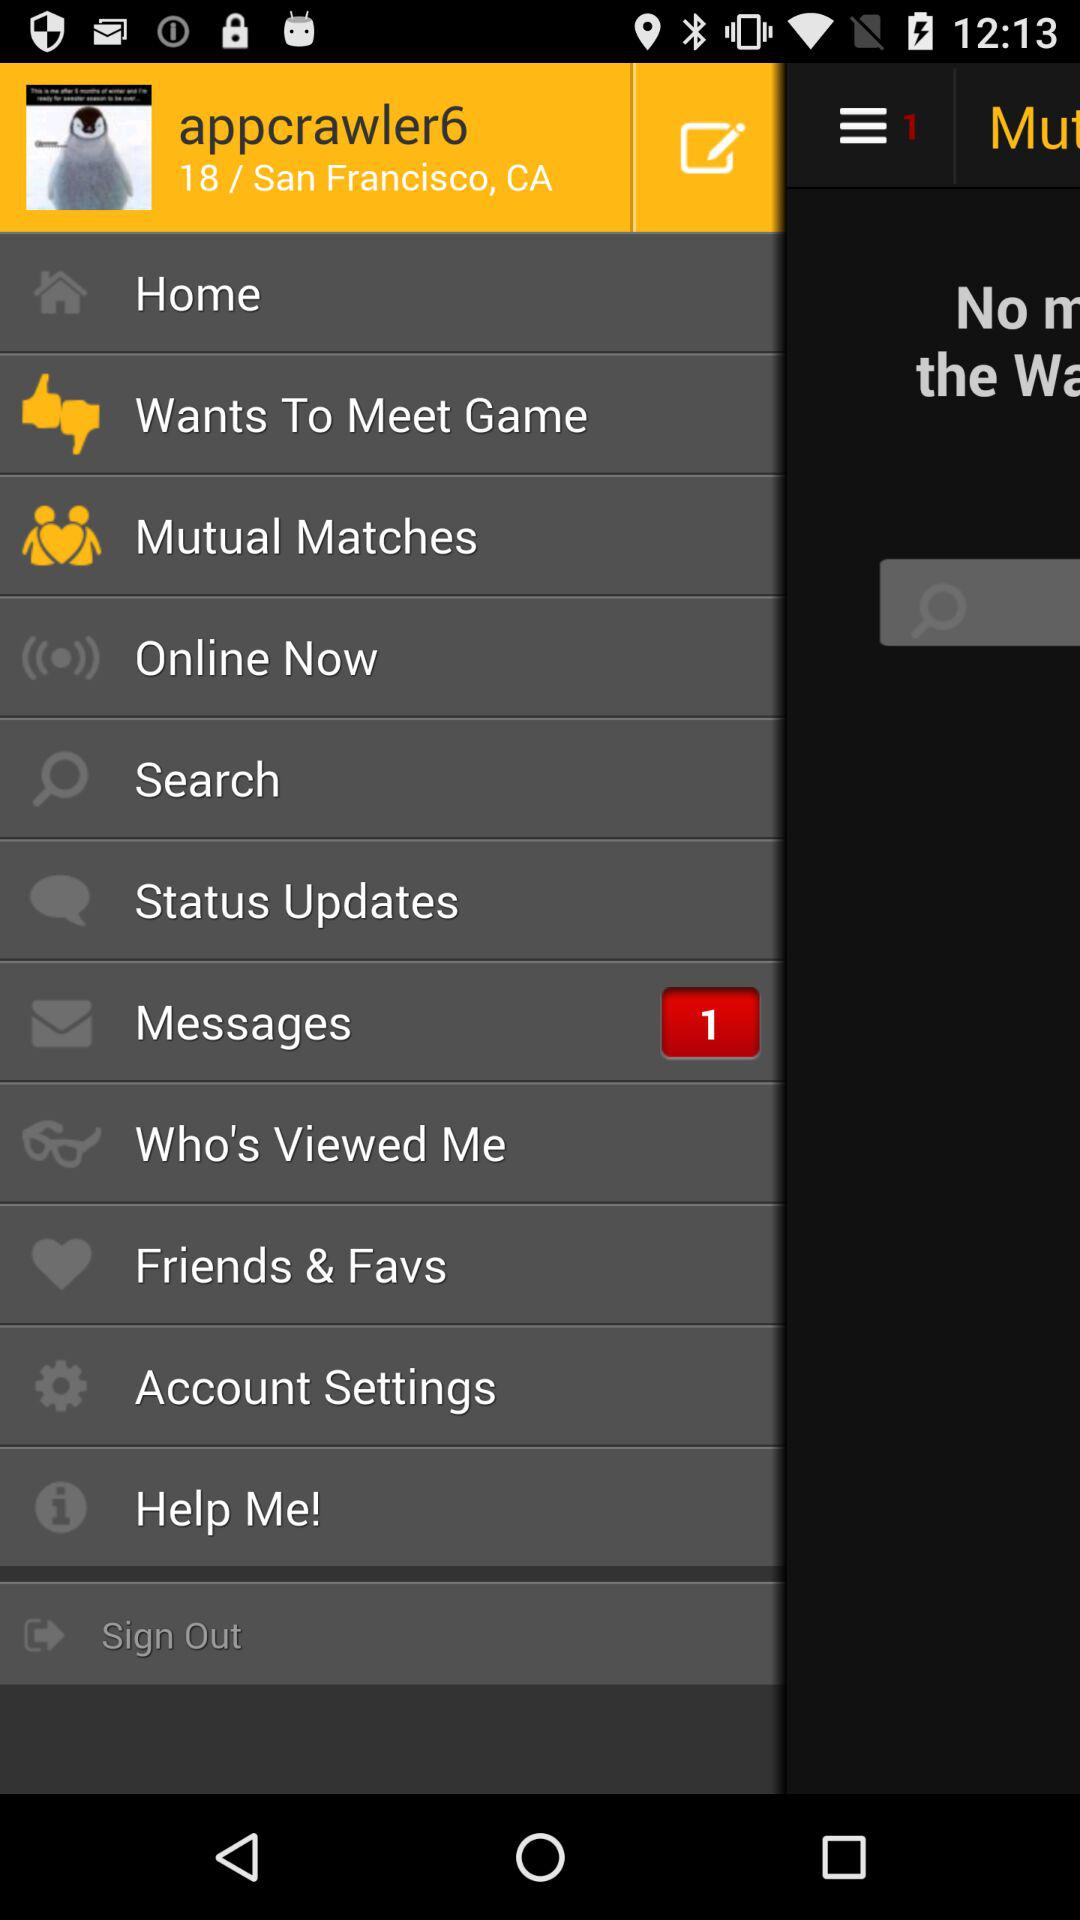How many unread messages are there? There is 1 unread message. 